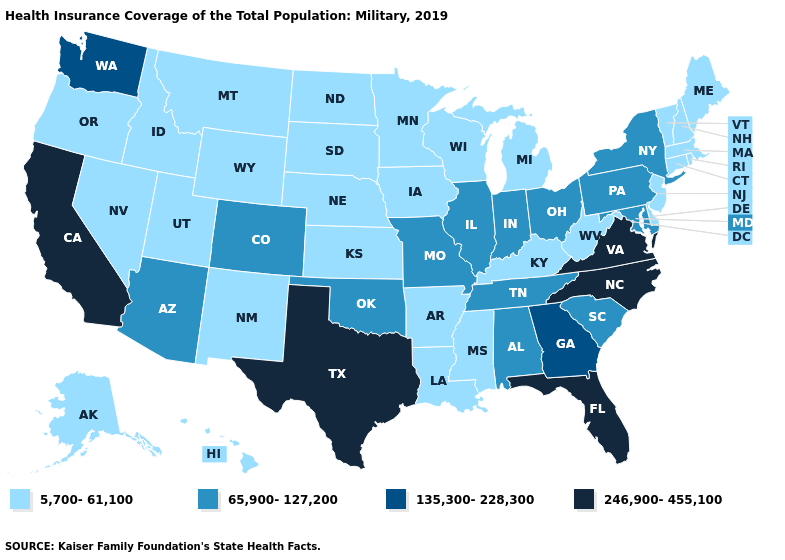Does New York have the highest value in the Northeast?
Answer briefly. Yes. Which states hav the highest value in the West?
Concise answer only. California. Is the legend a continuous bar?
Write a very short answer. No. Name the states that have a value in the range 65,900-127,200?
Give a very brief answer. Alabama, Arizona, Colorado, Illinois, Indiana, Maryland, Missouri, New York, Ohio, Oklahoma, Pennsylvania, South Carolina, Tennessee. Name the states that have a value in the range 246,900-455,100?
Give a very brief answer. California, Florida, North Carolina, Texas, Virginia. Does Montana have the same value as Missouri?
Answer briefly. No. Which states have the lowest value in the USA?
Be succinct. Alaska, Arkansas, Connecticut, Delaware, Hawaii, Idaho, Iowa, Kansas, Kentucky, Louisiana, Maine, Massachusetts, Michigan, Minnesota, Mississippi, Montana, Nebraska, Nevada, New Hampshire, New Jersey, New Mexico, North Dakota, Oregon, Rhode Island, South Dakota, Utah, Vermont, West Virginia, Wisconsin, Wyoming. What is the highest value in states that border West Virginia?
Quick response, please. 246,900-455,100. What is the lowest value in states that border Michigan?
Quick response, please. 5,700-61,100. What is the value of Wyoming?
Concise answer only. 5,700-61,100. What is the value of North Dakota?
Concise answer only. 5,700-61,100. What is the lowest value in the USA?
Write a very short answer. 5,700-61,100. Does the map have missing data?
Give a very brief answer. No. What is the lowest value in states that border Wyoming?
Write a very short answer. 5,700-61,100. What is the value of Missouri?
Keep it brief. 65,900-127,200. 